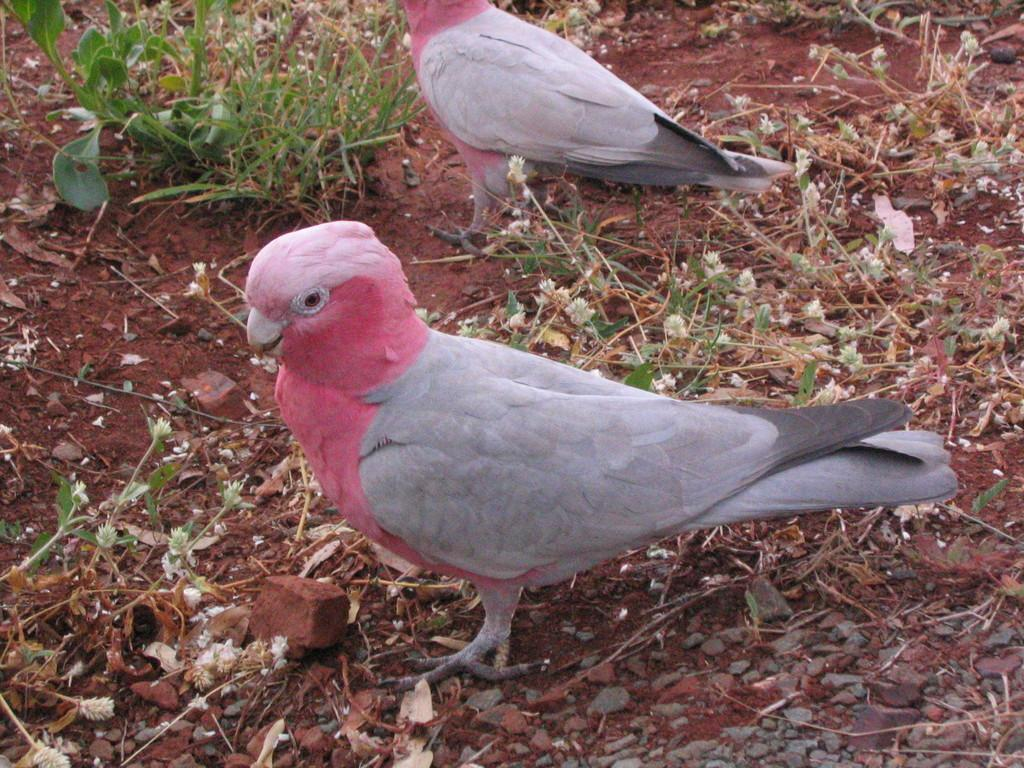How many birds can be seen in the image? There are two birds in the image. What are the birds doing in the image? The birds are standing on the ground. What type of terrain is visible in the image? There are stones, grass, and plants in the image. What type of gun is being used by the bird in the image? There is no gun present in the image; the birds are simply standing on the ground. Can you tell me how many pages are in the notebook that the bird is holding in the image? There is no notebook present in the image; the birds are not holding any objects. 